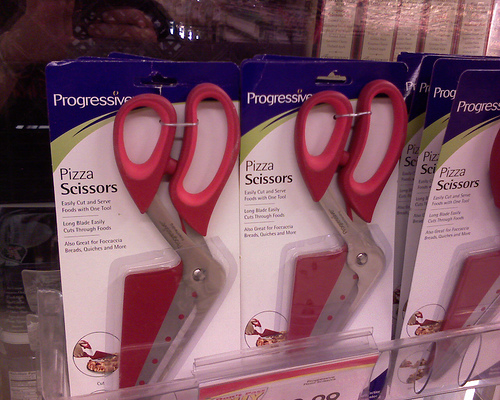<image>
Is the scissor to the left of the scissor? Yes. From this viewpoint, the scissor is positioned to the left side relative to the scissor. 